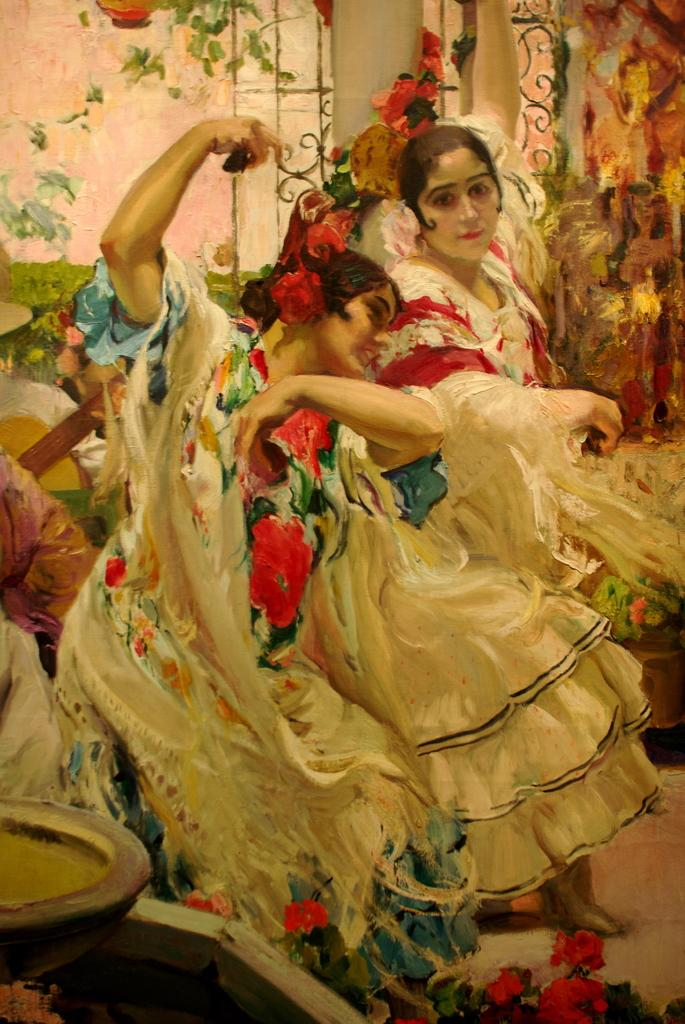What is the main subject of the image? There is a painting in the image. What is depicted in the painting? The painting contains two women. What type of shop can be seen in the painting? There is no shop present in the painting; it only contains two women. What is the level of friction between the two women in the painting? There is no indication of friction between the two women in the painting, as it is a static image. 